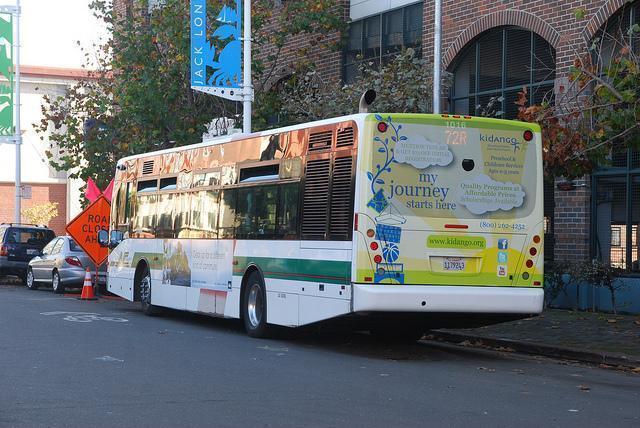What word is on the orange sign?
Indicate the correct choice and explain in the format: 'Answer: answer
Rationale: rationale.'
Options: Road, leave, stop, beware. Answer: road.
Rationale: That is the first word. 